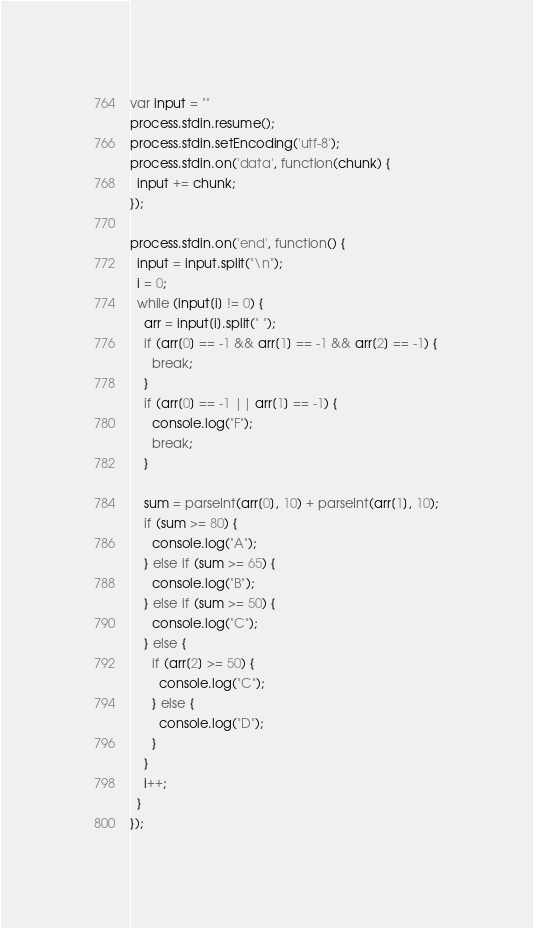<code> <loc_0><loc_0><loc_500><loc_500><_JavaScript_>var input = ""
process.stdin.resume();
process.stdin.setEncoding('utf-8');
process.stdin.on('data', function(chunk) {
  input += chunk;
});
 
process.stdin.on('end', function() {
  input = input.split("\n");
  i = 0;
  while (input[i] != 0) {
    arr = input[i].split(" ");
    if (arr[0] == -1 && arr[1] == -1 && arr[2] == -1) {
      break;
    }
    if (arr[0] == -1 || arr[1] == -1) {
      console.log("F");
      break;
    }

    sum = parseInt(arr[0], 10) + parseInt(arr[1], 10);
    if (sum >= 80) {
      console.log("A");
    } else if (sum >= 65) {
      console.log("B");
    } else if (sum >= 50) {
      console.log("C");
    } else {
      if (arr[2] >= 50) {
        console.log("C");
      } else {
        console.log("D");
      }
    }
    i++;
  }
});</code> 